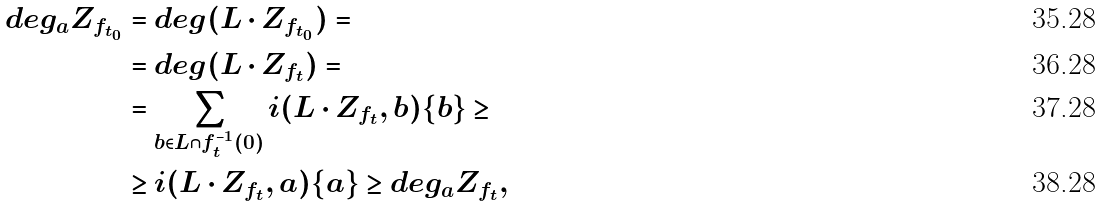Convert formula to latex. <formula><loc_0><loc_0><loc_500><loc_500>d e g _ { a } Z _ { f _ { t _ { 0 } } } & = d e g ( L \cdot Z _ { f _ { t _ { 0 } } } ) = \\ & = d e g ( L \cdot Z _ { f _ { t } } ) = \\ & = \sum _ { b \in L \cap f _ { t } ^ { - 1 } ( 0 ) } i ( L \cdot Z _ { f _ { t } } , b ) \{ b \} \geq \\ & \geq i ( L \cdot Z _ { f _ { t } } , a ) \{ a \} \geq d e g _ { a } Z _ { f _ { t } } ,</formula> 